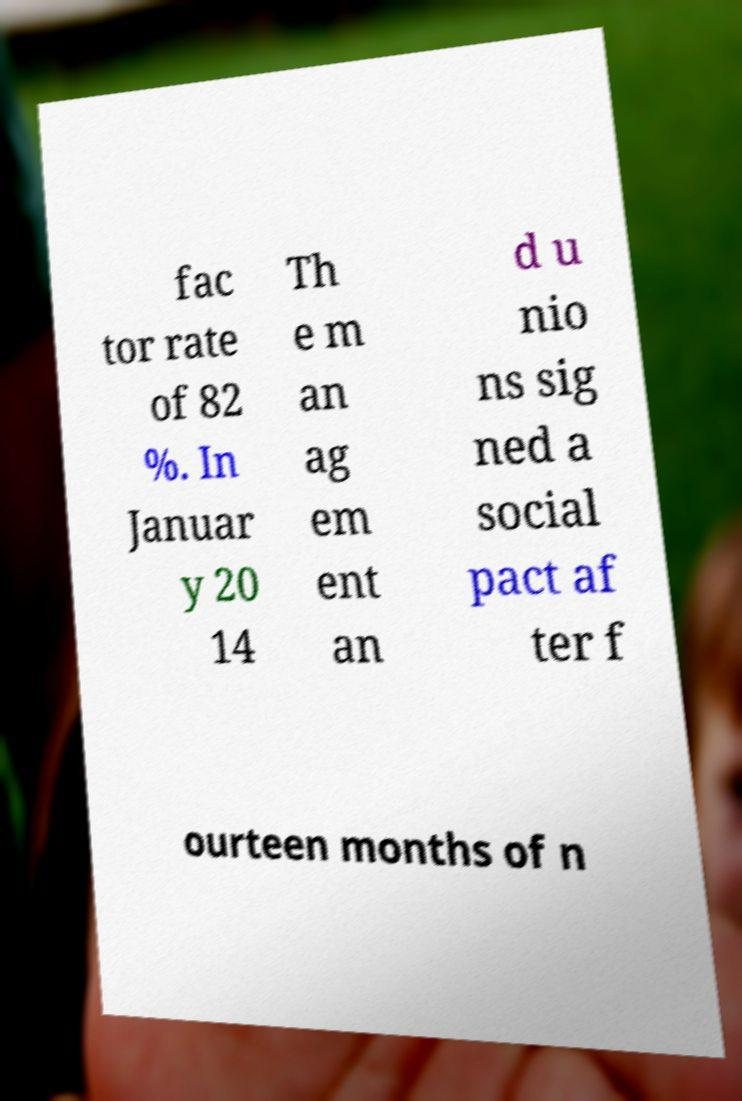Please read and relay the text visible in this image. What does it say? fac tor rate of 82 %. In Januar y 20 14 Th e m an ag em ent an d u nio ns sig ned a social pact af ter f ourteen months of n 